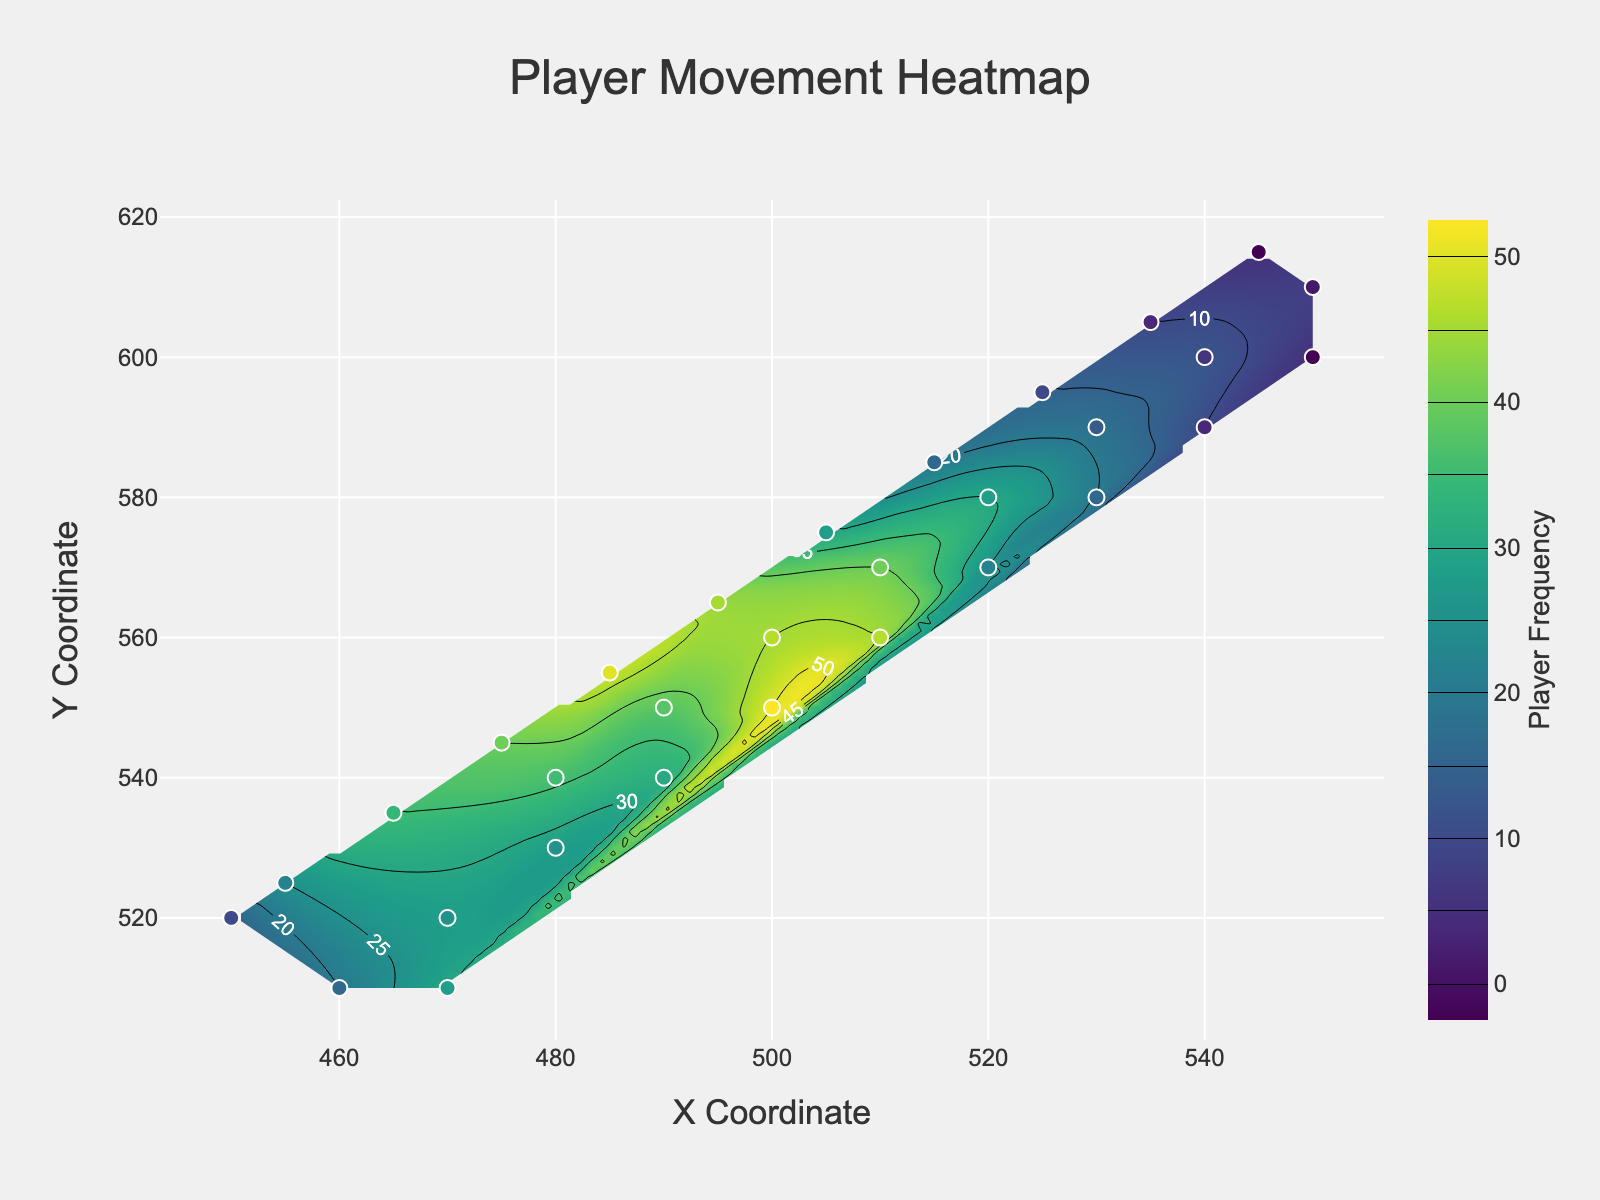What is the title of the figure? The title of the figure is prominently displayed at the top center of the plot. It reads "Player Movement Heatmap".
Answer: Player Movement Heatmap What are the axis labels on the plot? The x-axis is labeled "X Coordinate", and the y-axis is labeled "Y Coordinate". These labels are found near the respective axes.
Answer: X Coordinate and Y Coordinate How many contour levels are shown in the heatmap? The contour levels, visible as lines distinguishing different heat frequency areas, range from 0 to 50 in steps of 5. These levels indicate various player frequencies.
Answer: 11 Where is the highest player activity located on the plot? The highest player activity is indicated by the darkest region on the heatmap. This region is centered around the coordinates (500, 550) with a contour level closest to 50.
Answer: Around coordinates (500, 550) Compare the player activity at coordinate (480, 540) to that at (500, 560). Which one is higher? The plot shows that the frequency at (480, 540) is 36, while at (500, 560) it is 45. This information can be found from the data points represented as scatter markers and their colors.
Answer: (500, 560) What is the color scheme used in the heatmap? The heatmap uses the Viridis color scheme, which transitions from dark blue (low frequencies) to bright yellow (high frequencies). This is visible from the color gradient used in the plot.
Answer: Viridis Identify the contour line enclosing the frequency value of 25. To find this contour line, look for the labels on the contour lines and locate the one marked with 25. It encloses the area around coordinates such as (470, 520).
Answer: Around (470, 520) Calculate the difference in player frequency between coordinates (470, 510) and (530, 580). The player frequency at (470, 510) is 30, and at (530, 580) it is 18. The difference is calculated as 30 - 18.
Answer: 12 What is the overall trend of player movement frequency as you move from the bottom-left to the top-right of the plot? By observing the contour lines and colors, it is evident that the player frequency increases as you move from the bottom-left (low values) towards the top-right (higher values). This can be seen as the colors change from darker to brighter.
Answer: Increases What is the color used for the scatter plot markers, and how does its size relate to the data? The scatter plot markers use a color scale similar to the Viridis color scheme and their sizes correlate with the player frequency values, with higher values having larger marker sizes. This is observed from the different sizes of the markers across the plot.
Answer: Viridis; larger sizes for higher frequencies 